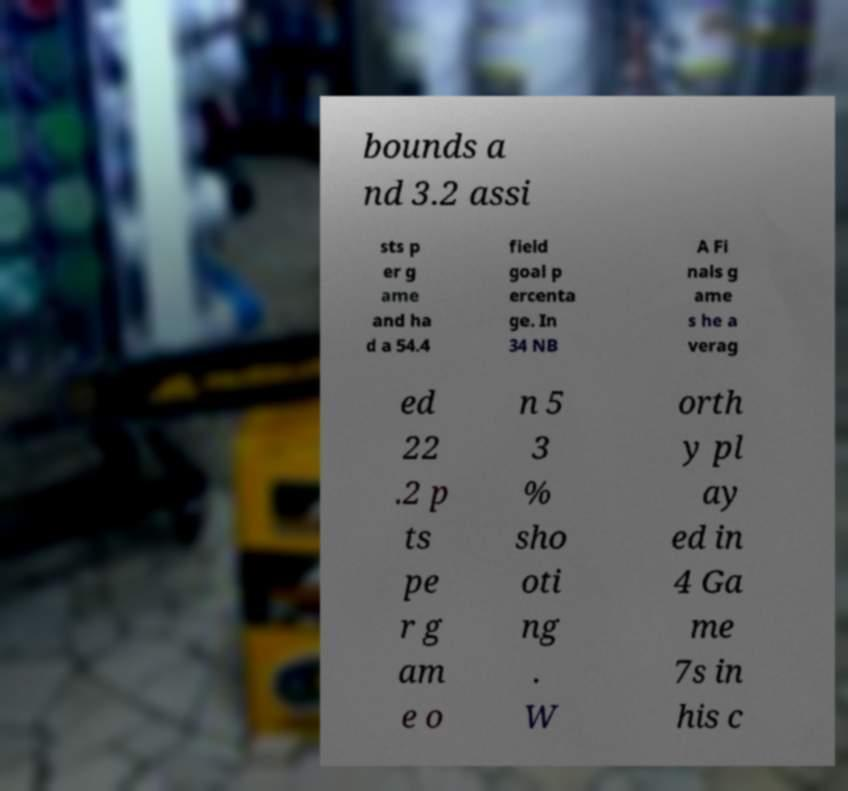Can you accurately transcribe the text from the provided image for me? bounds a nd 3.2 assi sts p er g ame and ha d a 54.4 field goal p ercenta ge. In 34 NB A Fi nals g ame s he a verag ed 22 .2 p ts pe r g am e o n 5 3 % sho oti ng . W orth y pl ay ed in 4 Ga me 7s in his c 